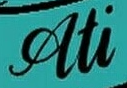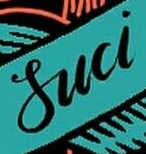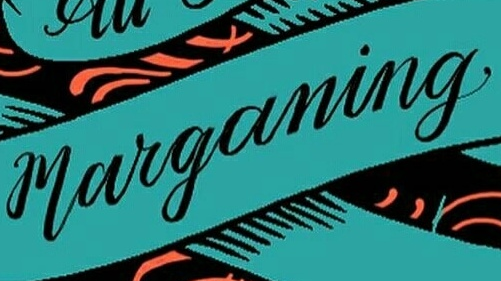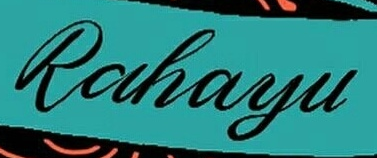What words can you see in these images in sequence, separated by a semicolon? Ati; Suci; marganing; Rahayu 